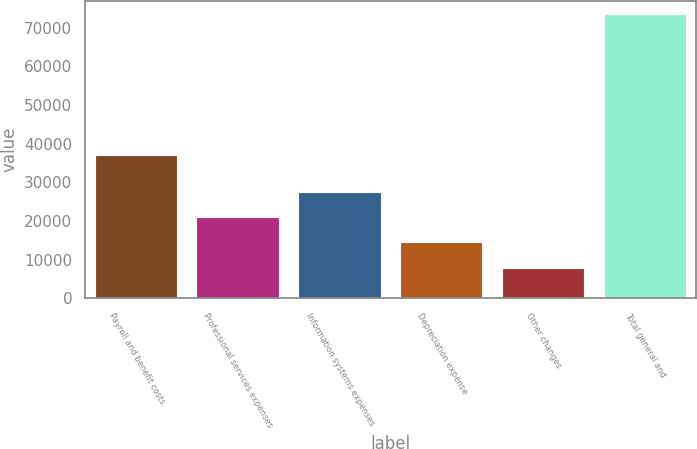Convert chart. <chart><loc_0><loc_0><loc_500><loc_500><bar_chart><fcel>Payroll and benefit costs<fcel>Professional services expenses<fcel>Information systems expenses<fcel>Depreciation expense<fcel>Other changes<fcel>Total general and<nl><fcel>36833<fcel>20758.6<fcel>27317.4<fcel>14199.8<fcel>7641<fcel>73229<nl></chart> 